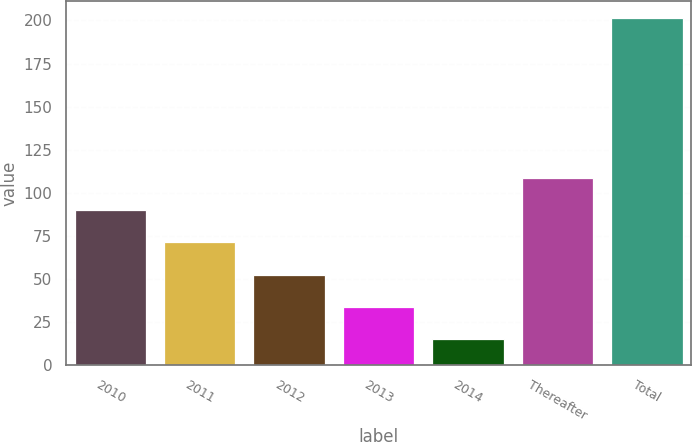Convert chart. <chart><loc_0><loc_0><loc_500><loc_500><bar_chart><fcel>2010<fcel>2011<fcel>2012<fcel>2013<fcel>2014<fcel>Thereafter<fcel>Total<nl><fcel>89.8<fcel>71.2<fcel>52.6<fcel>34<fcel>15.4<fcel>108.4<fcel>201.4<nl></chart> 